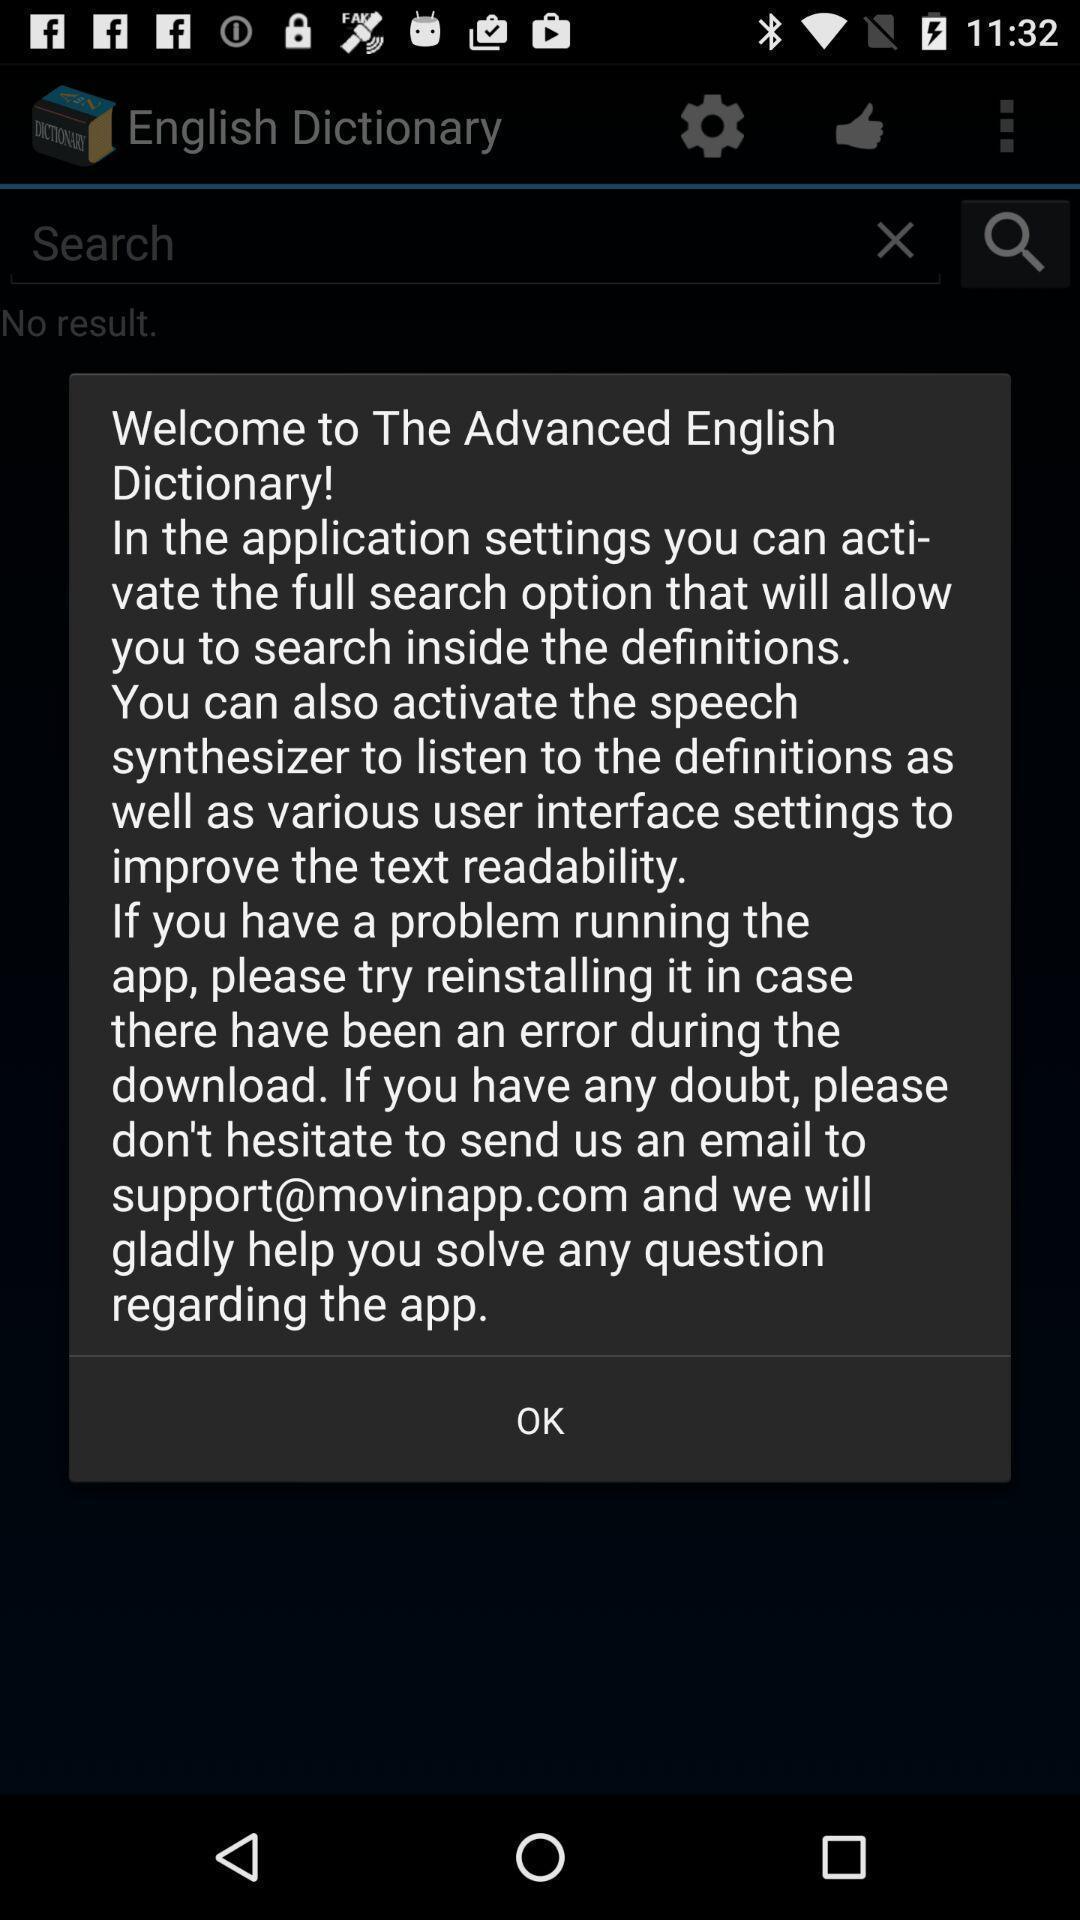Please provide a description for this image. Welcome message. 